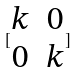<formula> <loc_0><loc_0><loc_500><loc_500>[ \begin{matrix} k & 0 \\ 0 & k \end{matrix} ]</formula> 